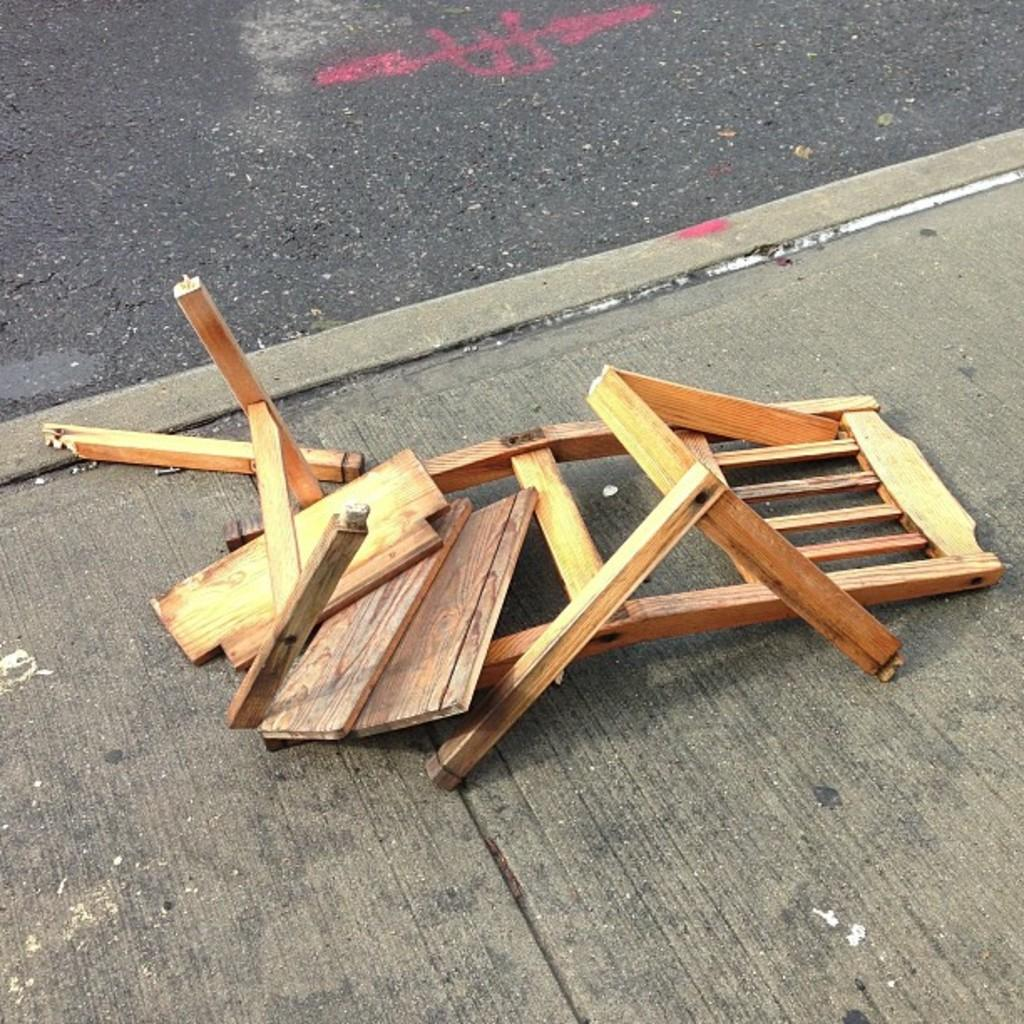What type of chair is in the image? There is a broken wooden chair in the image. Where is the chair located? The chair is placed on the road. What type of root can be seen growing from the chair in the image? There is no root growing from the chair in the image; it is a broken wooden chair placed on the road. Who is the creator of the jelly that is visible in the image? There is no jelly present in the image, so it is not possible to determine the creator of any jelly. 